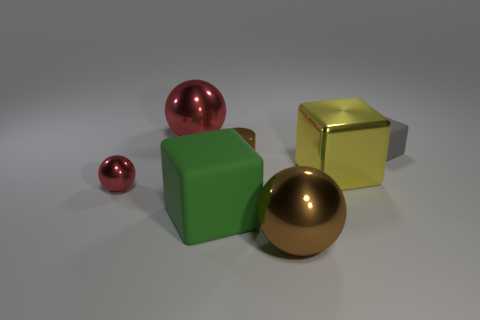How many other things are there of the same size as the brown shiny sphere?
Your answer should be compact. 3. There is a big object that is behind the yellow thing; what is its color?
Provide a succinct answer. Red. Do the large ball behind the brown metallic ball and the tiny block have the same material?
Provide a succinct answer. No. What number of big metallic things are both in front of the gray matte object and on the left side of the yellow metallic object?
Your response must be concise. 1. There is a big cube on the right side of the tiny shiny object right of the red sphere that is in front of the tiny rubber cube; what color is it?
Make the answer very short. Yellow. What number of other things are there of the same shape as the small brown shiny thing?
Keep it short and to the point. 0. Are there any shiny cubes that are right of the red sphere behind the small red thing?
Your answer should be compact. Yes. How many matte things are small objects or tiny cyan cylinders?
Provide a succinct answer. 1. The ball that is to the left of the small metallic cylinder and in front of the metallic block is made of what material?
Your answer should be very brief. Metal. There is a red shiny object in front of the big ball that is left of the big green cube; are there any tiny spheres right of it?
Offer a very short reply. No. 